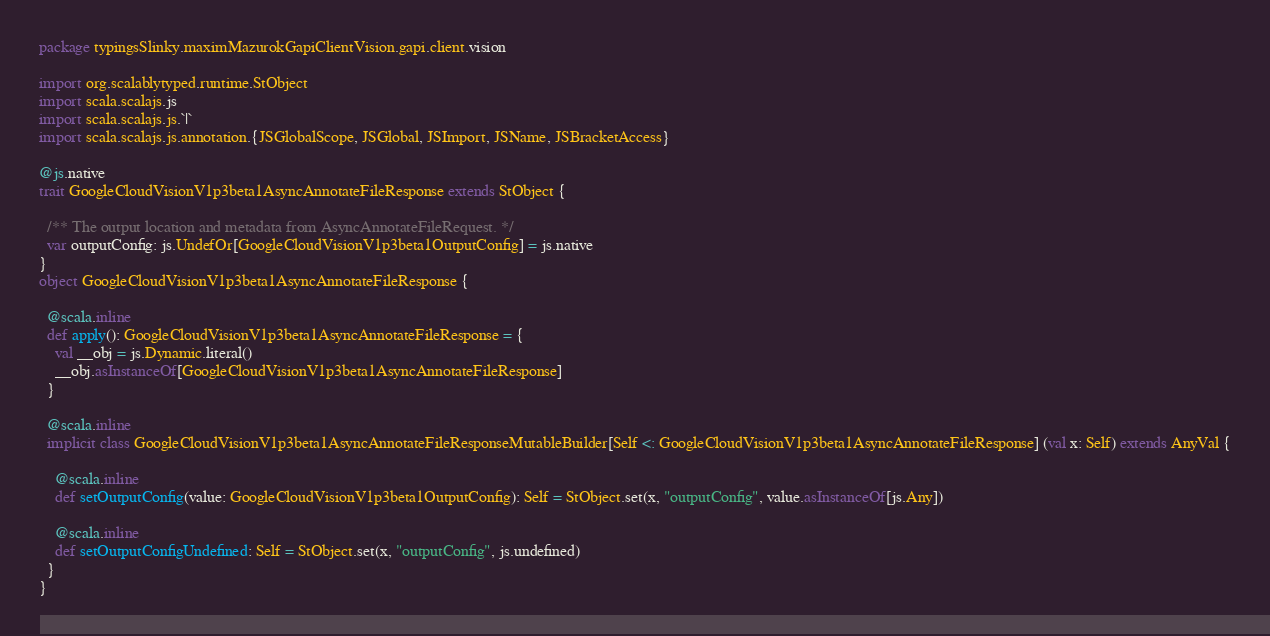<code> <loc_0><loc_0><loc_500><loc_500><_Scala_>package typingsSlinky.maximMazurokGapiClientVision.gapi.client.vision

import org.scalablytyped.runtime.StObject
import scala.scalajs.js
import scala.scalajs.js.`|`
import scala.scalajs.js.annotation.{JSGlobalScope, JSGlobal, JSImport, JSName, JSBracketAccess}

@js.native
trait GoogleCloudVisionV1p3beta1AsyncAnnotateFileResponse extends StObject {
  
  /** The output location and metadata from AsyncAnnotateFileRequest. */
  var outputConfig: js.UndefOr[GoogleCloudVisionV1p3beta1OutputConfig] = js.native
}
object GoogleCloudVisionV1p3beta1AsyncAnnotateFileResponse {
  
  @scala.inline
  def apply(): GoogleCloudVisionV1p3beta1AsyncAnnotateFileResponse = {
    val __obj = js.Dynamic.literal()
    __obj.asInstanceOf[GoogleCloudVisionV1p3beta1AsyncAnnotateFileResponse]
  }
  
  @scala.inline
  implicit class GoogleCloudVisionV1p3beta1AsyncAnnotateFileResponseMutableBuilder[Self <: GoogleCloudVisionV1p3beta1AsyncAnnotateFileResponse] (val x: Self) extends AnyVal {
    
    @scala.inline
    def setOutputConfig(value: GoogleCloudVisionV1p3beta1OutputConfig): Self = StObject.set(x, "outputConfig", value.asInstanceOf[js.Any])
    
    @scala.inline
    def setOutputConfigUndefined: Self = StObject.set(x, "outputConfig", js.undefined)
  }
}
</code> 